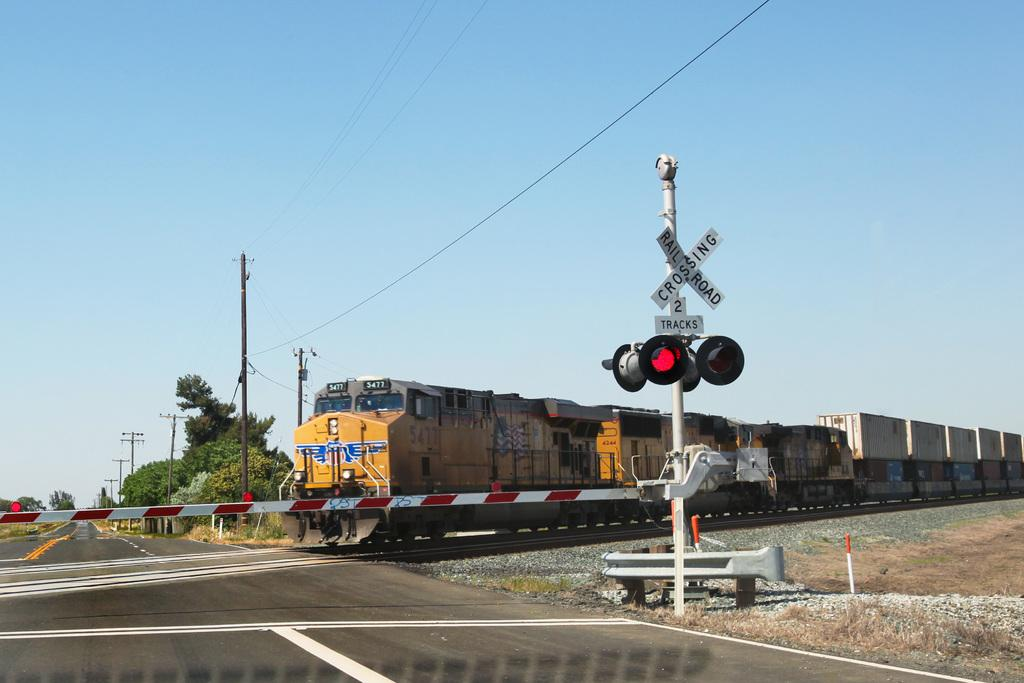<image>
Create a compact narrative representing the image presented. A train goes across a road behind a railroad crossing sign. 